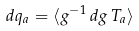Convert formula to latex. <formula><loc_0><loc_0><loc_500><loc_500>d q _ { a } = \langle g ^ { - 1 } \, d g \, T _ { a } \rangle</formula> 